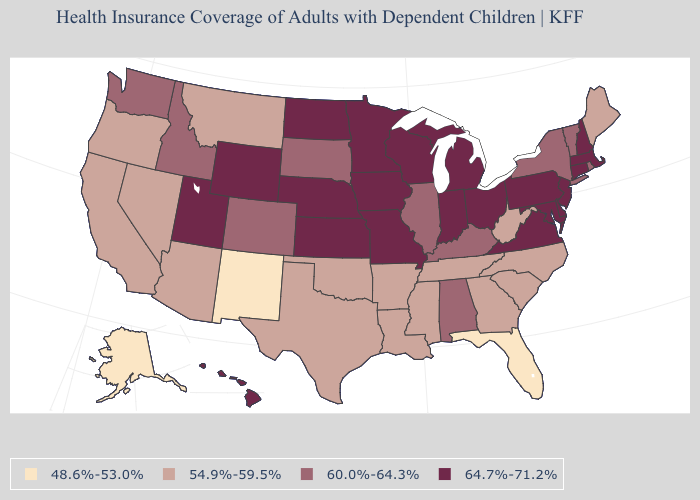Is the legend a continuous bar?
Give a very brief answer. No. Name the states that have a value in the range 60.0%-64.3%?
Short answer required. Alabama, Colorado, Idaho, Illinois, Kentucky, New York, Rhode Island, South Dakota, Vermont, Washington. Is the legend a continuous bar?
Keep it brief. No. Among the states that border Texas , which have the highest value?
Concise answer only. Arkansas, Louisiana, Oklahoma. Does the first symbol in the legend represent the smallest category?
Give a very brief answer. Yes. Is the legend a continuous bar?
Quick response, please. No. Name the states that have a value in the range 54.9%-59.5%?
Concise answer only. Arizona, Arkansas, California, Georgia, Louisiana, Maine, Mississippi, Montana, Nevada, North Carolina, Oklahoma, Oregon, South Carolina, Tennessee, Texas, West Virginia. Does Arizona have the lowest value in the USA?
Answer briefly. No. What is the value of Rhode Island?
Answer briefly. 60.0%-64.3%. Among the states that border Connecticut , which have the highest value?
Give a very brief answer. Massachusetts. Name the states that have a value in the range 54.9%-59.5%?
Keep it brief. Arizona, Arkansas, California, Georgia, Louisiana, Maine, Mississippi, Montana, Nevada, North Carolina, Oklahoma, Oregon, South Carolina, Tennessee, Texas, West Virginia. Does the map have missing data?
Be succinct. No. What is the value of Maryland?
Write a very short answer. 64.7%-71.2%. Name the states that have a value in the range 48.6%-53.0%?
Be succinct. Alaska, Florida, New Mexico. 